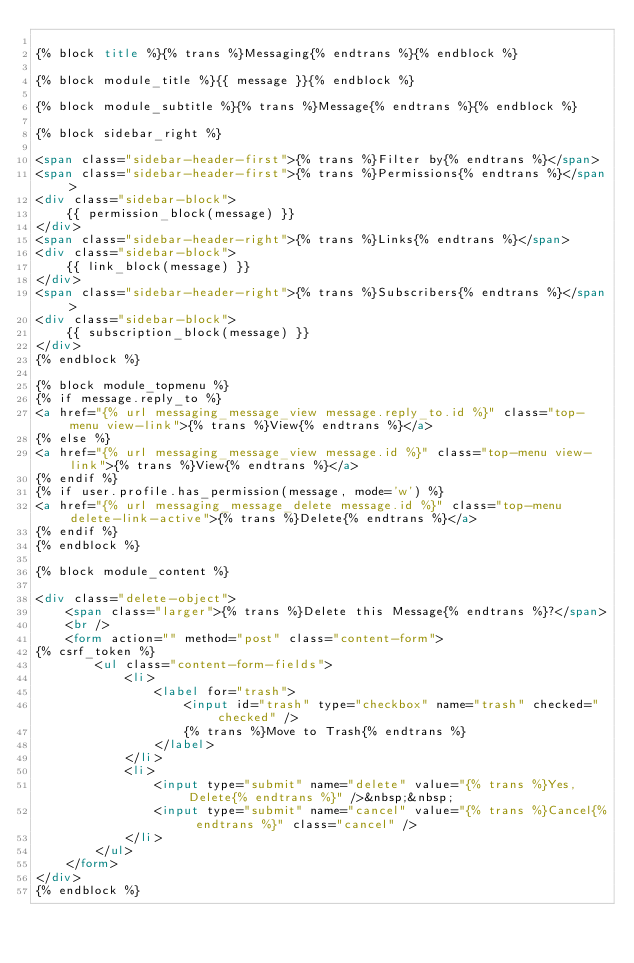Convert code to text. <code><loc_0><loc_0><loc_500><loc_500><_HTML_>
{% block title %}{% trans %}Messaging{% endtrans %}{% endblock %}

{% block module_title %}{{ message }}{% endblock %}

{% block module_subtitle %}{% trans %}Message{% endtrans %}{% endblock %}

{% block sidebar_right %}

<span class="sidebar-header-first">{% trans %}Filter by{% endtrans %}</span>
<span class="sidebar-header-first">{% trans %}Permissions{% endtrans %}</span>
<div class="sidebar-block">
    {{ permission_block(message) }}
</div>
<span class="sidebar-header-right">{% trans %}Links{% endtrans %}</span>
<div class="sidebar-block">
    {{ link_block(message) }}
</div>
<span class="sidebar-header-right">{% trans %}Subscribers{% endtrans %}</span>
<div class="sidebar-block">
    {{ subscription_block(message) }}
</div>
{% endblock %}

{% block module_topmenu %}
{% if message.reply_to %}
<a href="{% url messaging_message_view message.reply_to.id %}" class="top-menu view-link">{% trans %}View{% endtrans %}</a>
{% else %}
<a href="{% url messaging_message_view message.id %}" class="top-menu view-link">{% trans %}View{% endtrans %}</a>
{% endif %}
{% if user.profile.has_permission(message, mode='w') %}
<a href="{% url messaging_message_delete message.id %}" class="top-menu delete-link-active">{% trans %}Delete{% endtrans %}</a>
{% endif %}
{% endblock %}

{% block module_content %}

<div class="delete-object">
    <span class="larger">{% trans %}Delete this Message{% endtrans %}?</span>
    <br />
    <form action="" method="post" class="content-form">
{% csrf_token %}
        <ul class="content-form-fields">
            <li>
                <label for="trash">
                    <input id="trash" type="checkbox" name="trash" checked="checked" />
                    {% trans %}Move to Trash{% endtrans %}
                </label>
            </li>
            <li>
                <input type="submit" name="delete" value="{% trans %}Yes, Delete{% endtrans %}" />&nbsp;&nbsp;
                <input type="submit" name="cancel" value="{% trans %}Cancel{% endtrans %}" class="cancel" />
            </li>
        </ul>
    </form>
</div>
{% endblock %}
</code> 